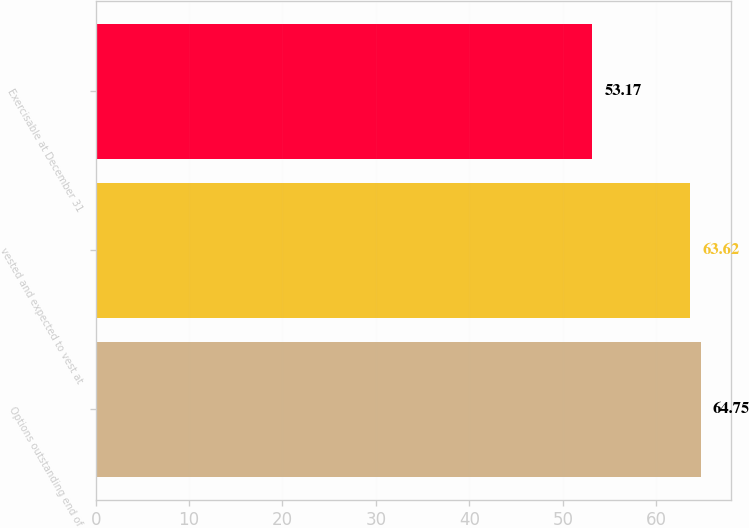Convert chart. <chart><loc_0><loc_0><loc_500><loc_500><bar_chart><fcel>Options outstanding end of<fcel>vested and expected to vest at<fcel>Exercisable at December 31<nl><fcel>64.75<fcel>63.62<fcel>53.17<nl></chart> 